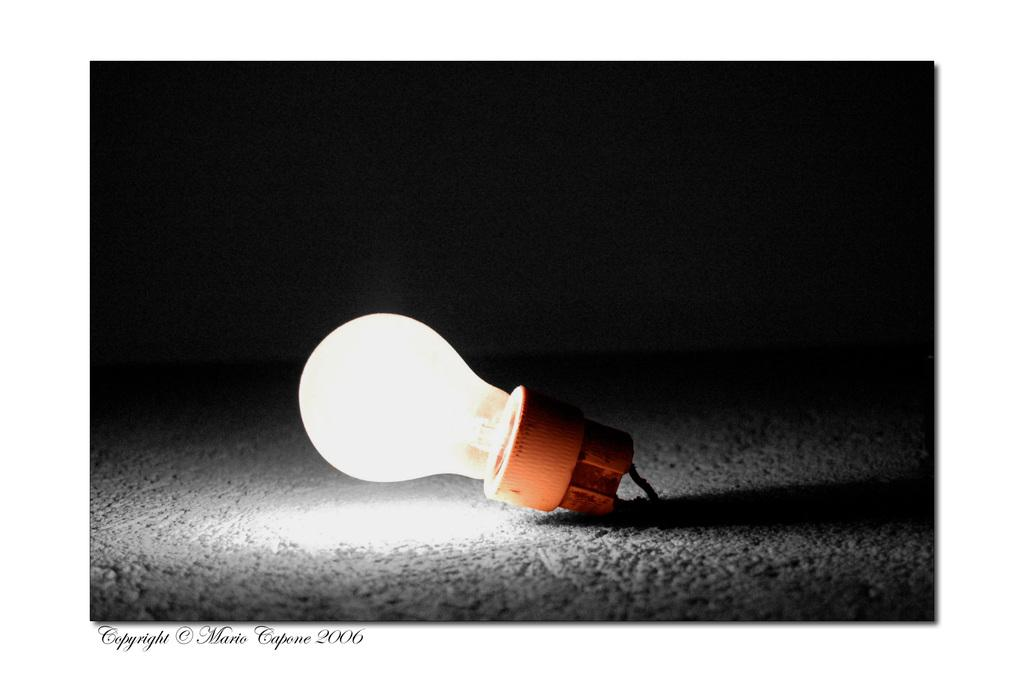What object is placed in the ground in the image? There is a bulb in the ground. What type of worm can be seen crawling on the bulb in the image? There are no worms present in the image; it only features a bulb in the ground. What kind of tent is set up near the bulb in the image? There is no tent present in the image; it only features a bulb in the ground. 